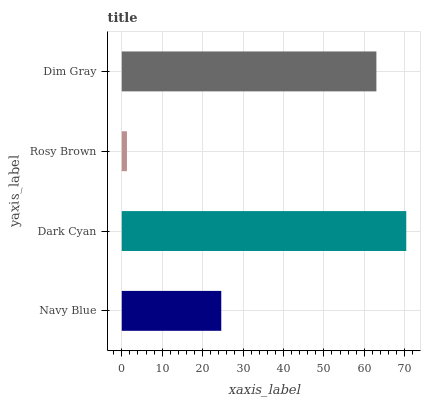Is Rosy Brown the minimum?
Answer yes or no. Yes. Is Dark Cyan the maximum?
Answer yes or no. Yes. Is Dark Cyan the minimum?
Answer yes or no. No. Is Rosy Brown the maximum?
Answer yes or no. No. Is Dark Cyan greater than Rosy Brown?
Answer yes or no. Yes. Is Rosy Brown less than Dark Cyan?
Answer yes or no. Yes. Is Rosy Brown greater than Dark Cyan?
Answer yes or no. No. Is Dark Cyan less than Rosy Brown?
Answer yes or no. No. Is Dim Gray the high median?
Answer yes or no. Yes. Is Navy Blue the low median?
Answer yes or no. Yes. Is Navy Blue the high median?
Answer yes or no. No. Is Dark Cyan the low median?
Answer yes or no. No. 